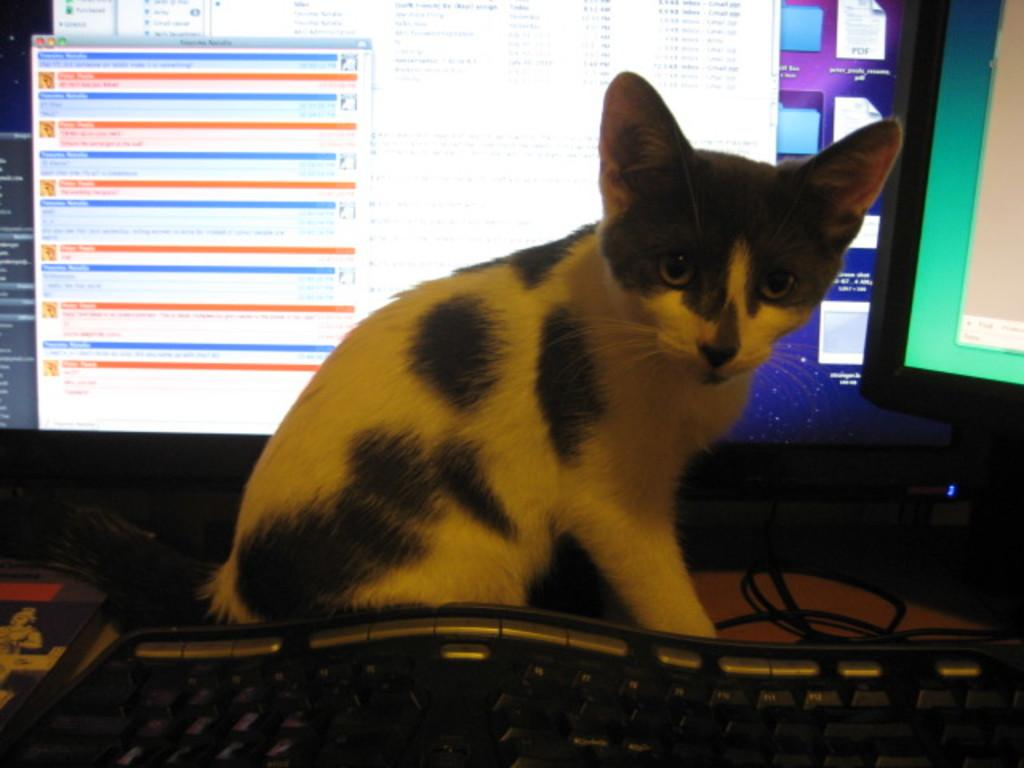What type of animal is present in the image? There is a cat in the image. What electronic devices can be seen in the image? There are screens and a keyboard visible in the image. What might be used for connecting or powering the electronic devices? Wires are present in the image for connecting or powering the devices. Can you describe the object on the left side of the image? Unfortunately, the facts provided do not specify the object on the left side of the image. Can you see any seashore or truck in the image? No, there is no seashore or truck present in the image. Is there an owl in the image? No, there is no owl present in the image. 